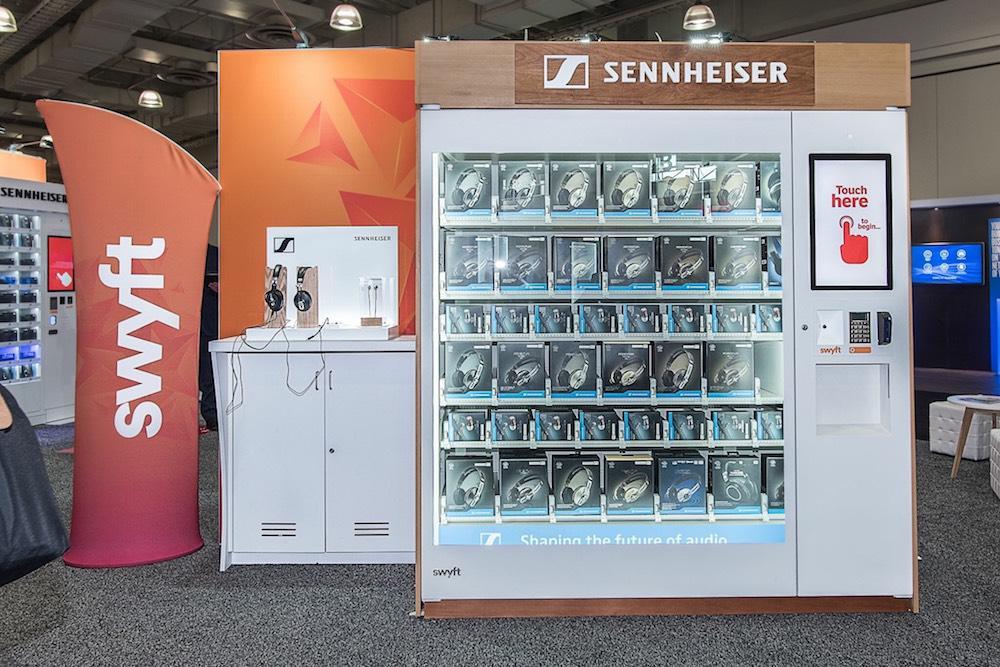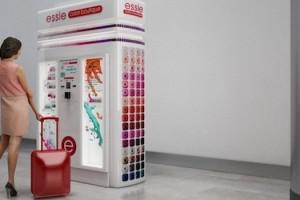The first image is the image on the left, the second image is the image on the right. Assess this claim about the two images: "One of the machines has a red cross on it.". Correct or not? Answer yes or no. No. The first image is the image on the left, the second image is the image on the right. Assess this claim about the two images: "One of the vending machines sells condoms.". Correct or not? Answer yes or no. No. 